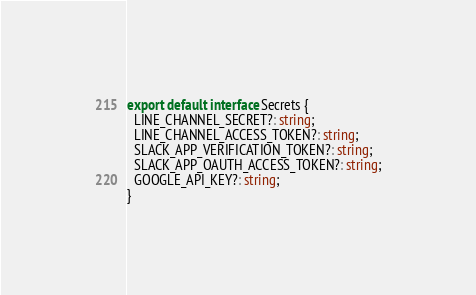Convert code to text. <code><loc_0><loc_0><loc_500><loc_500><_TypeScript_>export default interface Secrets {
  LINE_CHANNEL_SECRET?: string;
  LINE_CHANNEL_ACCESS_TOKEN?: string;
  SLACK_APP_VERIFICATION_TOKEN?: string;
  SLACK_APP_OAUTH_ACCESS_TOKEN?: string;
  GOOGLE_API_KEY?: string;
}
</code> 